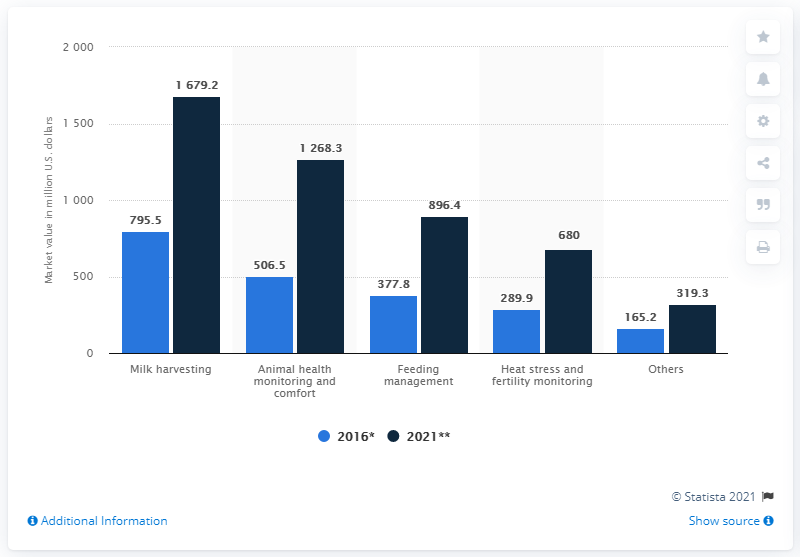Mention a couple of crucial points in this snapshot. In 2016, the market value of milk harvesting applications for global livestock monitoring was approximately 795.5. The market value of milk harvesting applications for global livestock monitoring is expected to reach $1679.2 million by 2021. 